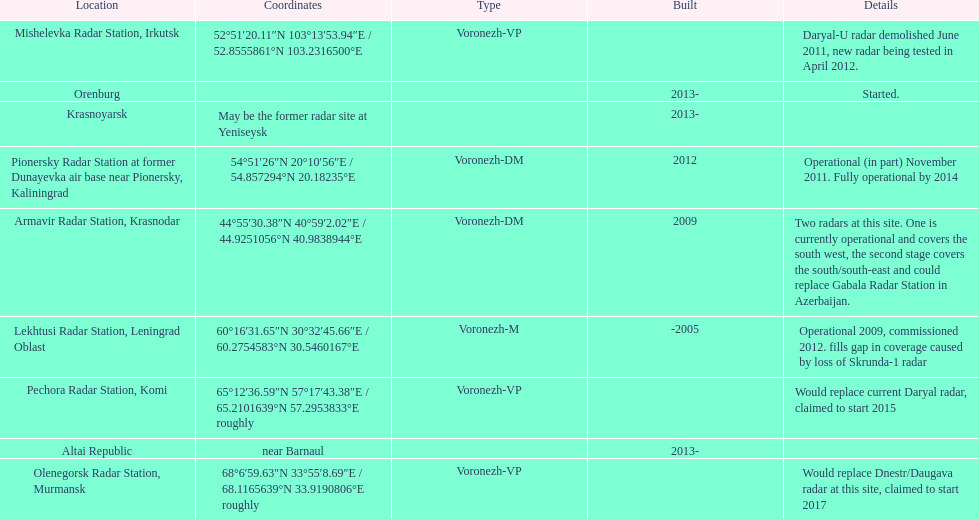Which voronezh radar has already started? Orenburg. Which radar would replace dnestr/daugava? Olenegorsk Radar Station, Murmansk. Which radar started in 2015? Pechora Radar Station, Komi. 